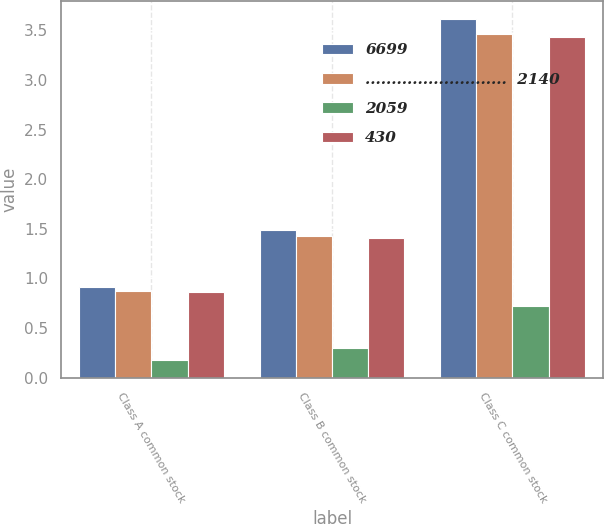Convert chart to OTSL. <chart><loc_0><loc_0><loc_500><loc_500><stacked_bar_chart><ecel><fcel>Class A common stock<fcel>Class B common stock<fcel>Class C common stock<nl><fcel>6699<fcel>0.91<fcel>1.49<fcel>3.62<nl><fcel>...........................  2140<fcel>0.87<fcel>1.43<fcel>3.46<nl><fcel>2059<fcel>0.18<fcel>0.3<fcel>0.72<nl><fcel>430<fcel>0.86<fcel>1.41<fcel>3.43<nl></chart> 